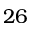<formula> <loc_0><loc_0><loc_500><loc_500>2 6</formula> 